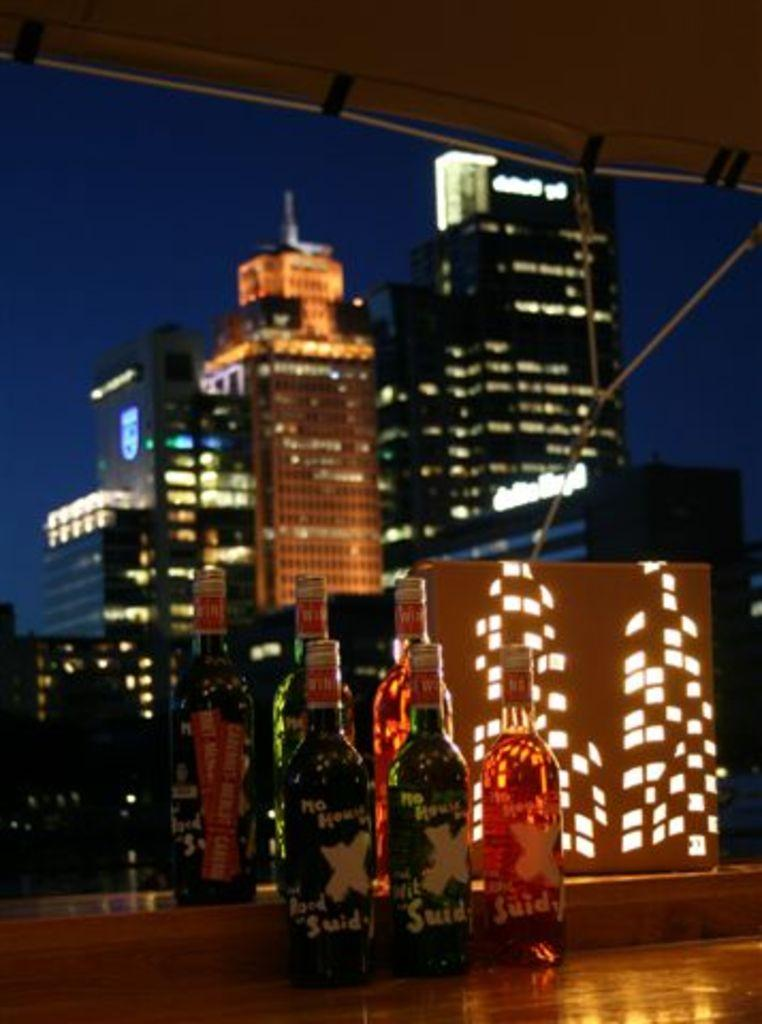<image>
Describe the image concisely. Six bottles of alcahol called suidy sit by a window with a city scene behind them. 